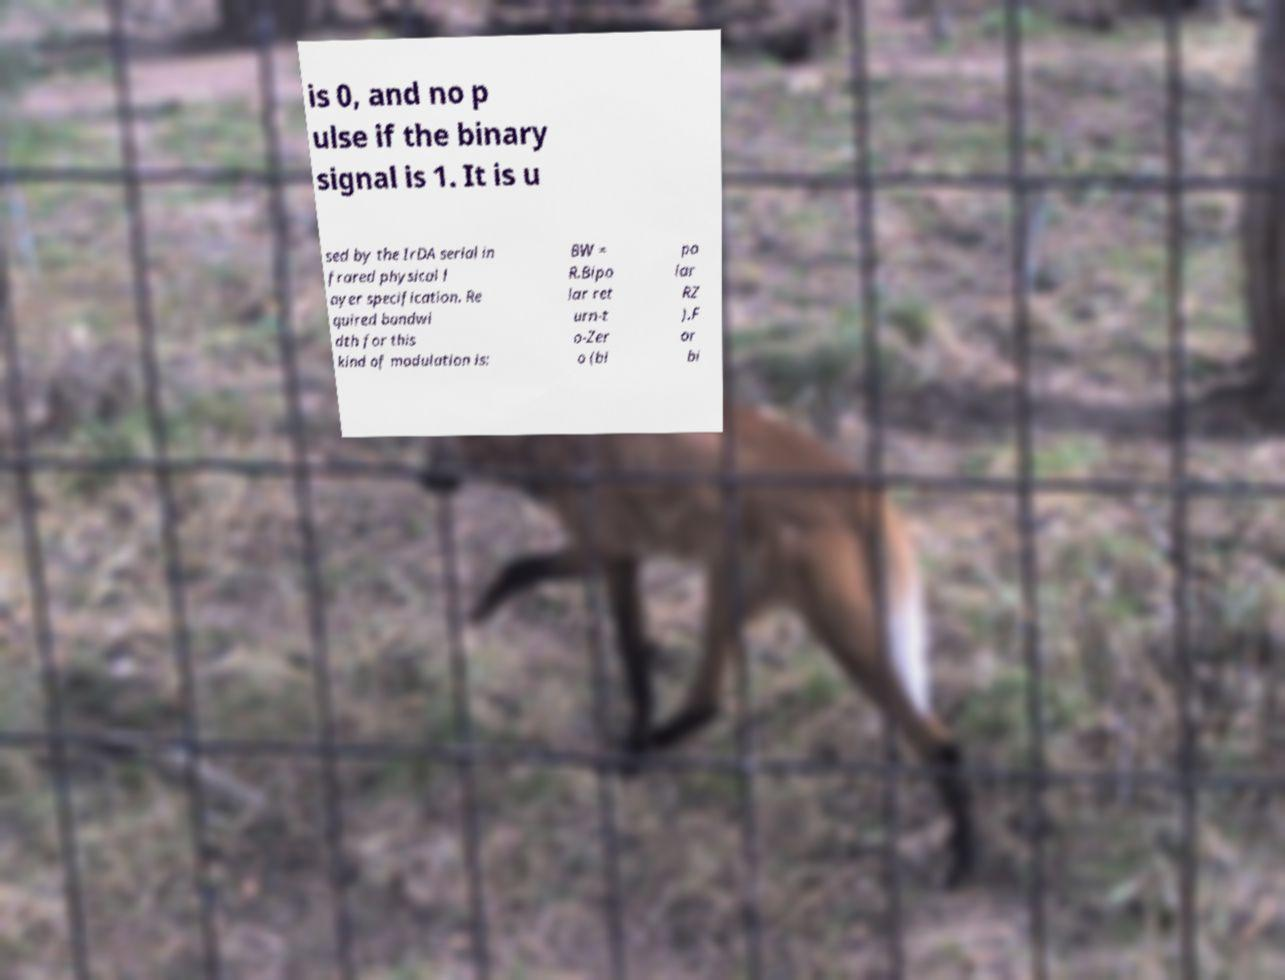Can you read and provide the text displayed in the image?This photo seems to have some interesting text. Can you extract and type it out for me? is 0, and no p ulse if the binary signal is 1. It is u sed by the IrDA serial in frared physical l ayer specification. Re quired bandwi dth for this kind of modulation is: BW = R.Bipo lar ret urn-t o-Zer o (bi po lar RZ ).F or bi 